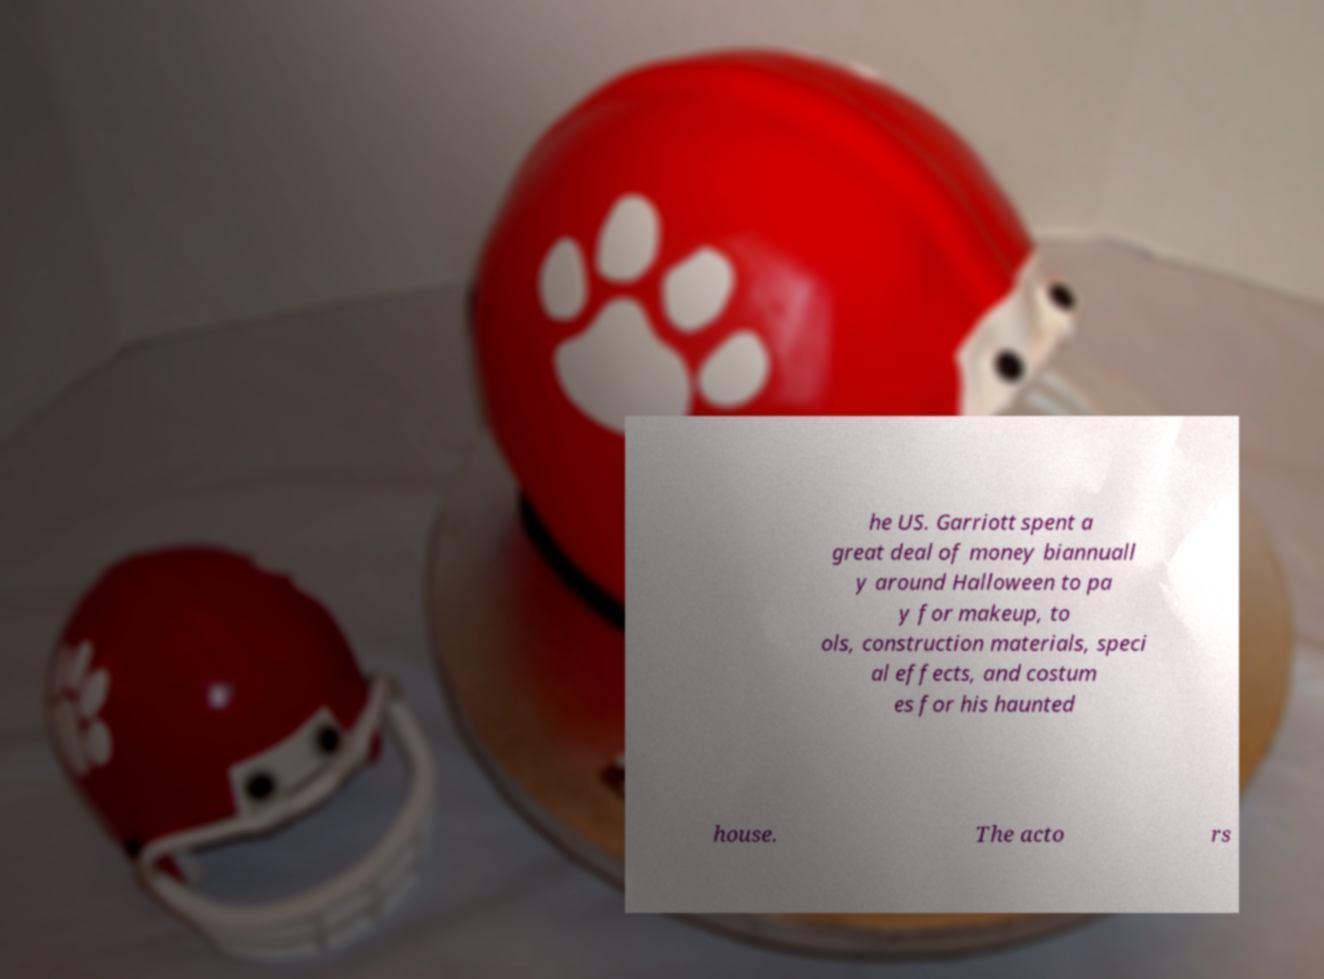Can you accurately transcribe the text from the provided image for me? he US. Garriott spent a great deal of money biannuall y around Halloween to pa y for makeup, to ols, construction materials, speci al effects, and costum es for his haunted house. The acto rs 